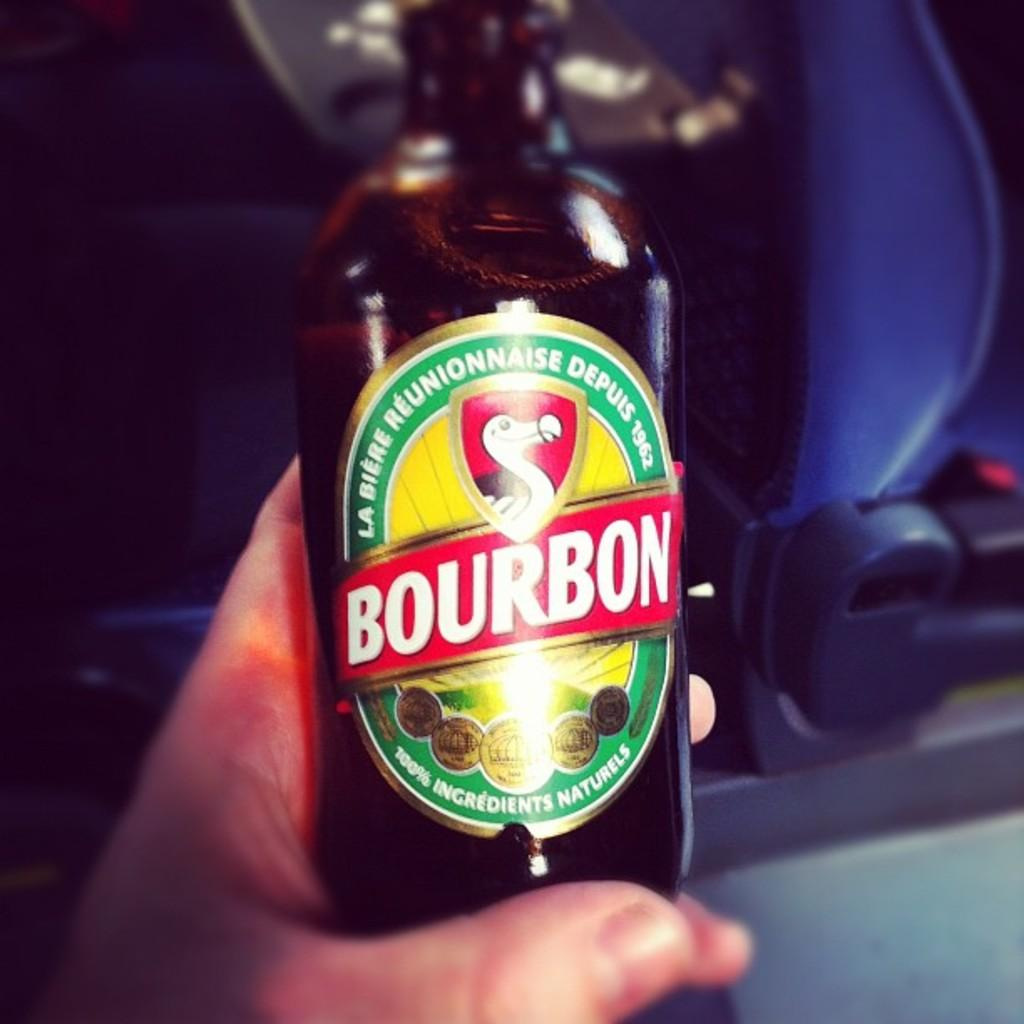<image>
Provide a brief description of the given image. A bottle of Bourbon claims to have 100% ingredients naturels 